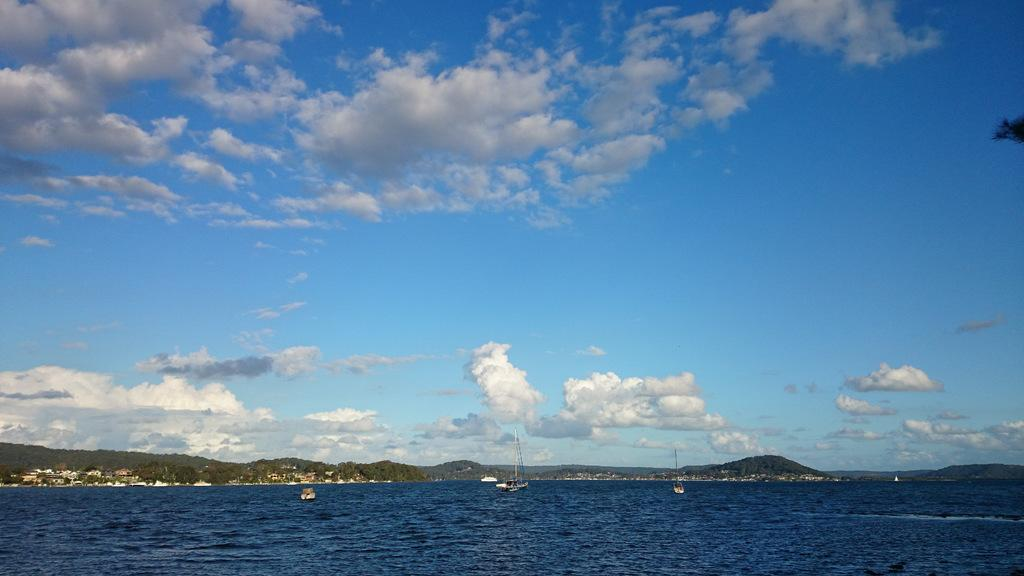What is at the bottom of the image? There is water at the bottom of the image. What is floating on the water? There are boats in the water. What can be seen in the distance in the image? There are trees and hills in the background of the image. What is visible at the top of the image? The sky is visible at the top of the image. What type of stew is being served on the boats in the image? There is no stew present in the image; it features water, boats, trees, hills, and the sky. Who is the porter responsible for maintaining the boats in the image? There is no information about a porter or boat maintenance in the image. 